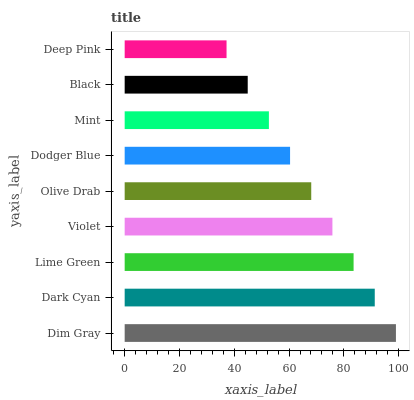Is Deep Pink the minimum?
Answer yes or no. Yes. Is Dim Gray the maximum?
Answer yes or no. Yes. Is Dark Cyan the minimum?
Answer yes or no. No. Is Dark Cyan the maximum?
Answer yes or no. No. Is Dim Gray greater than Dark Cyan?
Answer yes or no. Yes. Is Dark Cyan less than Dim Gray?
Answer yes or no. Yes. Is Dark Cyan greater than Dim Gray?
Answer yes or no. No. Is Dim Gray less than Dark Cyan?
Answer yes or no. No. Is Olive Drab the high median?
Answer yes or no. Yes. Is Olive Drab the low median?
Answer yes or no. Yes. Is Dodger Blue the high median?
Answer yes or no. No. Is Black the low median?
Answer yes or no. No. 